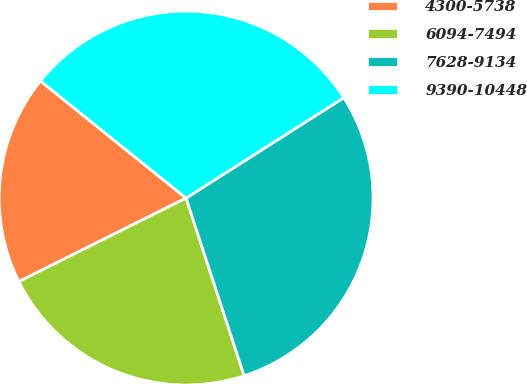Convert chart to OTSL. <chart><loc_0><loc_0><loc_500><loc_500><pie_chart><fcel>4300-5738<fcel>6094-7494<fcel>7628-9134<fcel>9390-10448<nl><fcel>18.15%<fcel>22.65%<fcel>29.0%<fcel>30.2%<nl></chart> 